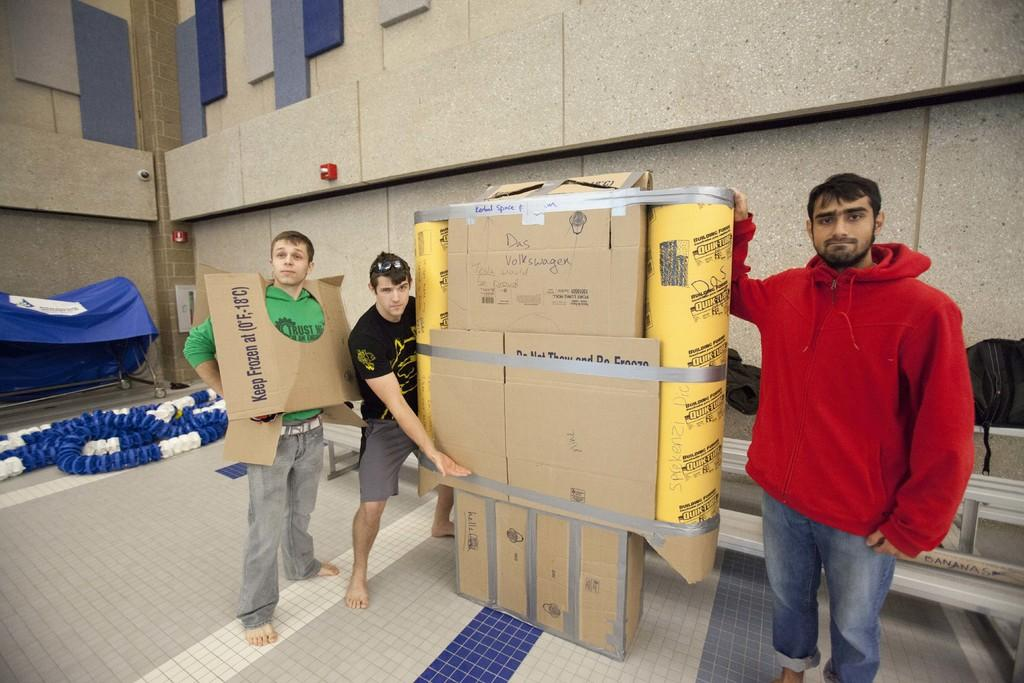<image>
Give a short and clear explanation of the subsequent image. three males in front of card board box creations reading Keep Frozen 